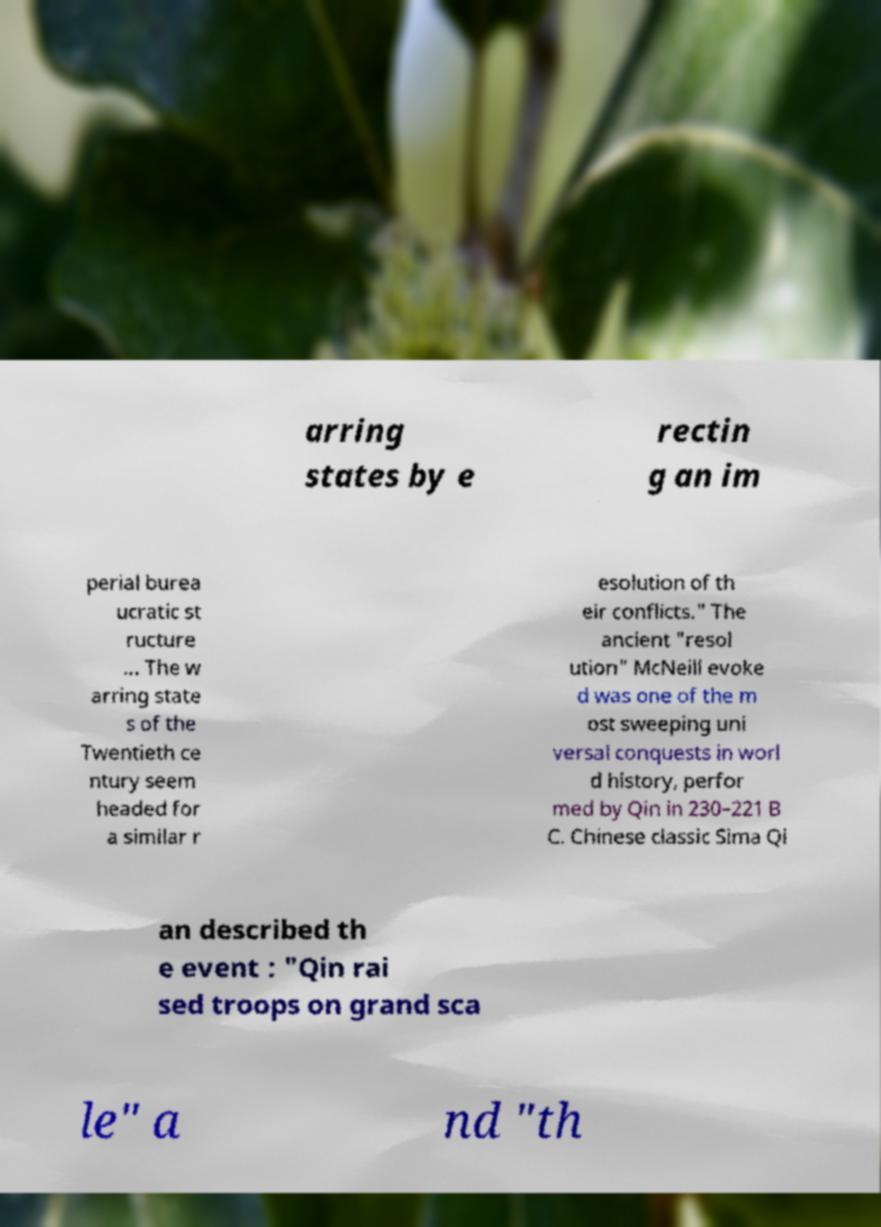Can you accurately transcribe the text from the provided image for me? arring states by e rectin g an im perial burea ucratic st ructure ... The w arring state s of the Twentieth ce ntury seem headed for a similar r esolution of th eir conflicts." The ancient "resol ution" McNeill evoke d was one of the m ost sweeping uni versal conquests in worl d history, perfor med by Qin in 230–221 B C. Chinese classic Sima Qi an described th e event : "Qin rai sed troops on grand sca le" a nd "th 